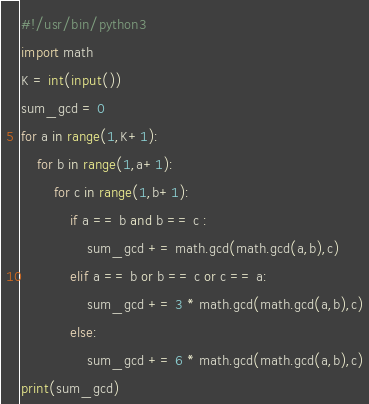<code> <loc_0><loc_0><loc_500><loc_500><_Python_>#!/usr/bin/python3
import math
K = int(input())
sum_gcd = 0
for a in range(1,K+1):
    for b in range(1,a+1):
        for c in range(1,b+1):
            if a == b and b == c :
                sum_gcd += math.gcd(math.gcd(a,b),c)
            elif a == b or b == c or c == a:
                sum_gcd += 3 * math.gcd(math.gcd(a,b),c)
            else:
                sum_gcd += 6 * math.gcd(math.gcd(a,b),c)
print(sum_gcd)</code> 